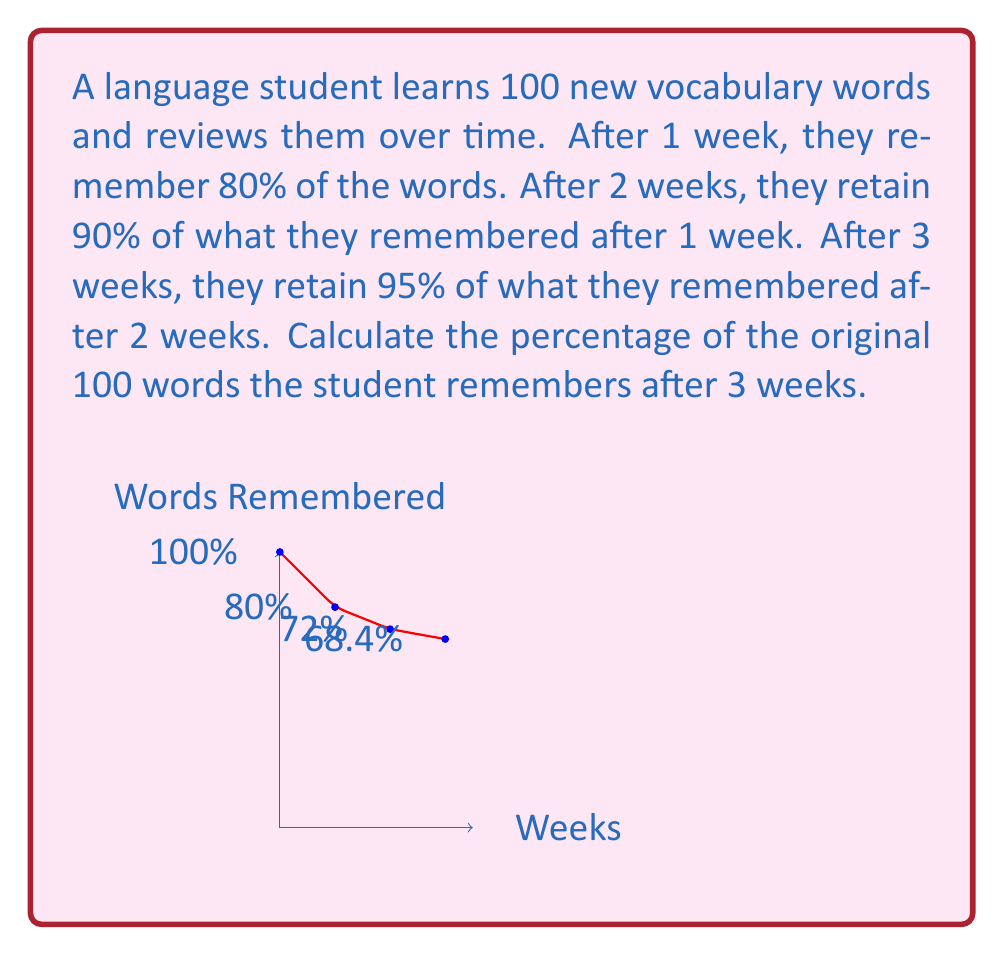Could you help me with this problem? Let's break this down step-by-step:

1) Initially, the student learns 100 words.

2) After 1 week:
   $100 \times 80\% = 100 \times 0.8 = 80$ words

3) After 2 weeks:
   $80 \times 90\% = 80 \times 0.9 = 72$ words

4) After 3 weeks:
   $72 \times 95\% = 72 \times 0.95 = 68.4$ words

5) To calculate the percentage of the original 100 words:
   $$\frac{68.4}{100} \times 100\% = 68.4\%$$

Therefore, after 3 weeks, the student remembers 68.4% of the original 100 words.
Answer: 68.4% 